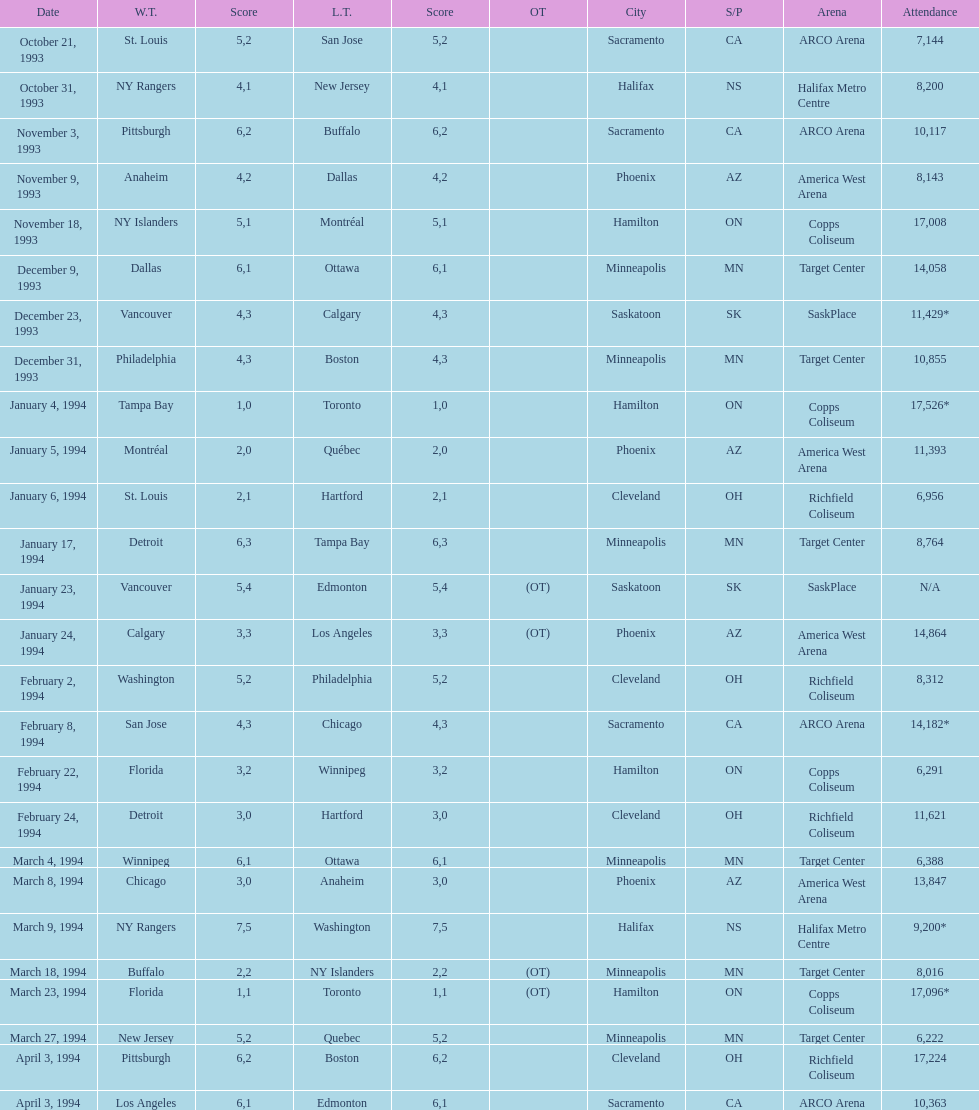Write the full table. {'header': ['Date', 'W.T.', 'Score', 'L.T.', 'Score', 'OT', 'City', 'S/P', 'Arena', 'Attendance'], 'rows': [['October 21, 1993', 'St. Louis', '5', 'San Jose', '2', '', 'Sacramento', 'CA', 'ARCO Arena', '7,144'], ['October 31, 1993', 'NY Rangers', '4', 'New Jersey', '1', '', 'Halifax', 'NS', 'Halifax Metro Centre', '8,200'], ['November 3, 1993', 'Pittsburgh', '6', 'Buffalo', '2', '', 'Sacramento', 'CA', 'ARCO Arena', '10,117'], ['November 9, 1993', 'Anaheim', '4', 'Dallas', '2', '', 'Phoenix', 'AZ', 'America West Arena', '8,143'], ['November 18, 1993', 'NY Islanders', '5', 'Montréal', '1', '', 'Hamilton', 'ON', 'Copps Coliseum', '17,008'], ['December 9, 1993', 'Dallas', '6', 'Ottawa', '1', '', 'Minneapolis', 'MN', 'Target Center', '14,058'], ['December 23, 1993', 'Vancouver', '4', 'Calgary', '3', '', 'Saskatoon', 'SK', 'SaskPlace', '11,429*'], ['December 31, 1993', 'Philadelphia', '4', 'Boston', '3', '', 'Minneapolis', 'MN', 'Target Center', '10,855'], ['January 4, 1994', 'Tampa Bay', '1', 'Toronto', '0', '', 'Hamilton', 'ON', 'Copps Coliseum', '17,526*'], ['January 5, 1994', 'Montréal', '2', 'Québec', '0', '', 'Phoenix', 'AZ', 'America West Arena', '11,393'], ['January 6, 1994', 'St. Louis', '2', 'Hartford', '1', '', 'Cleveland', 'OH', 'Richfield Coliseum', '6,956'], ['January 17, 1994', 'Detroit', '6', 'Tampa Bay', '3', '', 'Minneapolis', 'MN', 'Target Center', '8,764'], ['January 23, 1994', 'Vancouver', '5', 'Edmonton', '4', '(OT)', 'Saskatoon', 'SK', 'SaskPlace', 'N/A'], ['January 24, 1994', 'Calgary', '3', 'Los Angeles', '3', '(OT)', 'Phoenix', 'AZ', 'America West Arena', '14,864'], ['February 2, 1994', 'Washington', '5', 'Philadelphia', '2', '', 'Cleveland', 'OH', 'Richfield Coliseum', '8,312'], ['February 8, 1994', 'San Jose', '4', 'Chicago', '3', '', 'Sacramento', 'CA', 'ARCO Arena', '14,182*'], ['February 22, 1994', 'Florida', '3', 'Winnipeg', '2', '', 'Hamilton', 'ON', 'Copps Coliseum', '6,291'], ['February 24, 1994', 'Detroit', '3', 'Hartford', '0', '', 'Cleveland', 'OH', 'Richfield Coliseum', '11,621'], ['March 4, 1994', 'Winnipeg', '6', 'Ottawa', '1', '', 'Minneapolis', 'MN', 'Target Center', '6,388'], ['March 8, 1994', 'Chicago', '3', 'Anaheim', '0', '', 'Phoenix', 'AZ', 'America West Arena', '13,847'], ['March 9, 1994', 'NY Rangers', '7', 'Washington', '5', '', 'Halifax', 'NS', 'Halifax Metro Centre', '9,200*'], ['March 18, 1994', 'Buffalo', '2', 'NY Islanders', '2', '(OT)', 'Minneapolis', 'MN', 'Target Center', '8,016'], ['March 23, 1994', 'Florida', '1', 'Toronto', '1', '(OT)', 'Hamilton', 'ON', 'Copps Coliseum', '17,096*'], ['March 27, 1994', 'New Jersey', '5', 'Quebec', '2', '', 'Minneapolis', 'MN', 'Target Center', '6,222'], ['April 3, 1994', 'Pittsburgh', '6', 'Boston', '2', '', 'Cleveland', 'OH', 'Richfield Coliseum', '17,224'], ['April 3, 1994', 'Los Angeles', '6', 'Edmonton', '1', '', 'Sacramento', 'CA', 'ARCO Arena', '10,363']]} When was the first neutral site game to be won by tampa bay? January 4, 1994. 